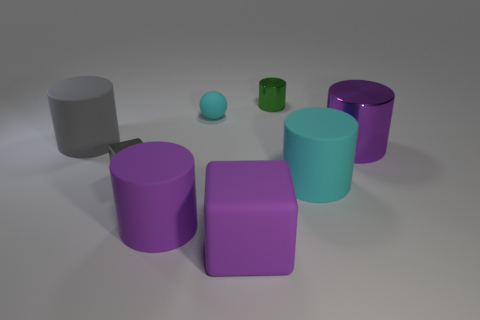Can you describe the colors of the objects in the image, and how many objects there are of each color? In the image, there are two purple cylindrical objects and one purple cube. There's one gray cube, one green cylinder, one blue cylinder, and one small spherical object that appears to be a light blue or teal. 